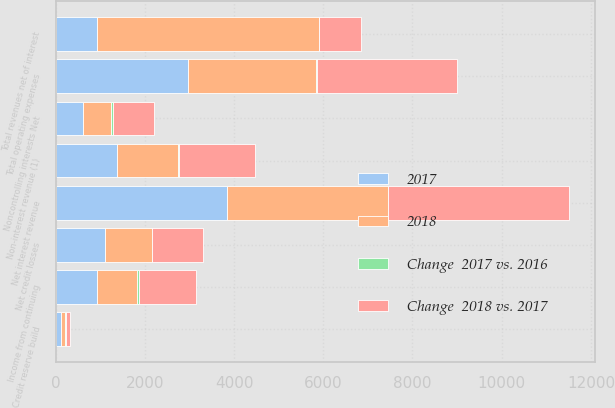<chart> <loc_0><loc_0><loc_500><loc_500><stacked_bar_chart><ecel><fcel>Net interest revenue<fcel>Non-interest revenue (1)<fcel>Total revenues net of interest<fcel>Total operating expenses<fcel>Net credit losses<fcel>Credit reserve build<fcel>Income from continuing<fcel>Noncontrolling interests Net<nl><fcel>Change  2018 vs. 2017<fcel>4058<fcel>1702<fcel>933.5<fcel>3156<fcel>1153<fcel>83<fcel>1287<fcel>928<nl><fcel>2017<fcel>3844<fcel>1378<fcel>933.5<fcel>2959<fcel>1117<fcel>125<fcel>939<fcel>605<nl><fcel>2018<fcel>3606<fcel>1365<fcel>4971<fcel>2885<fcel>1040<fcel>83<fcel>890<fcel>628<nl><fcel>Change  2017 vs. 2016<fcel>6<fcel>24<fcel>10<fcel>7<fcel>3<fcel>34<fcel>37<fcel>53<nl></chart> 